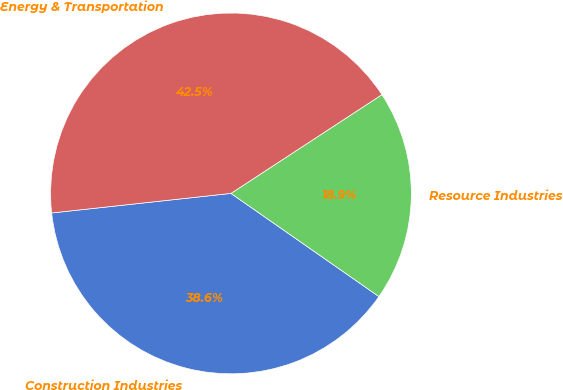Convert chart. <chart><loc_0><loc_0><loc_500><loc_500><pie_chart><fcel>Construction Industries<fcel>Resource Industries<fcel>Energy & Transportation<nl><fcel>38.58%<fcel>18.91%<fcel>42.51%<nl></chart> 